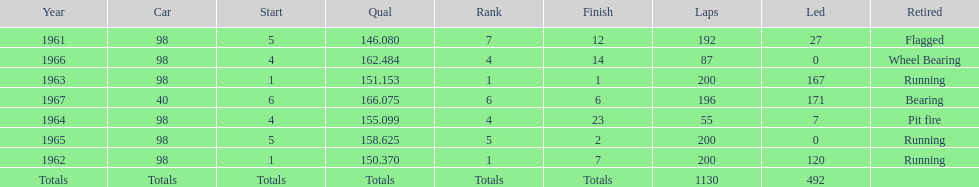Number of times to finish the races running. 3. Give me the full table as a dictionary. {'header': ['Year', 'Car', 'Start', 'Qual', 'Rank', 'Finish', 'Laps', 'Led', 'Retired'], 'rows': [['1961', '98', '5', '146.080', '7', '12', '192', '27', 'Flagged'], ['1966', '98', '4', '162.484', '4', '14', '87', '0', 'Wheel Bearing'], ['1963', '98', '1', '151.153', '1', '1', '200', '167', 'Running'], ['1967', '40', '6', '166.075', '6', '6', '196', '171', 'Bearing'], ['1964', '98', '4', '155.099', '4', '23', '55', '7', 'Pit fire'], ['1965', '98', '5', '158.625', '5', '2', '200', '0', 'Running'], ['1962', '98', '1', '150.370', '1', '7', '200', '120', 'Running'], ['Totals', 'Totals', 'Totals', 'Totals', 'Totals', 'Totals', '1130', '492', '']]} 